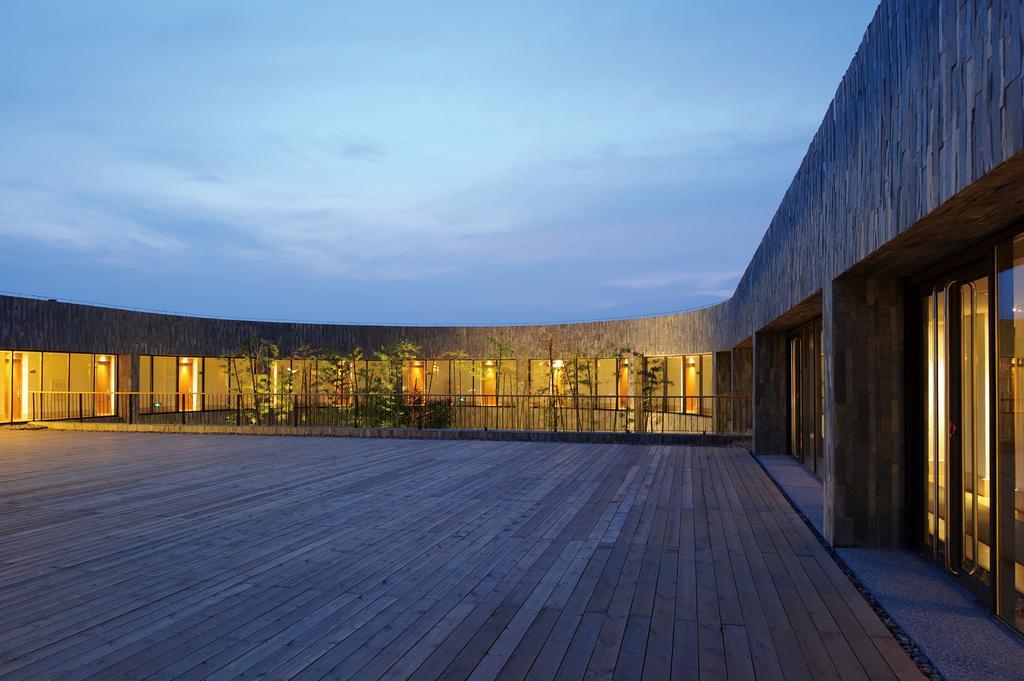Describe this image in one or two sentences. In this image at the bottom there is a wooden floor and in the background there is one house, lights, plants, doors and fence. On the top of the image there is sky. 